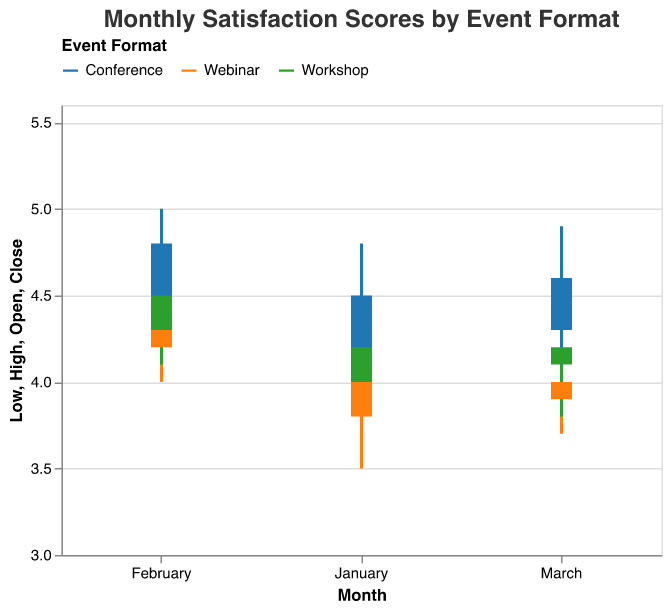What is the title of the plot? The title is usually placed at the top of the figure and is meant to inform the viewer about the overall topic of the plot. In this case, the title is "Monthly Satisfaction Scores by Event Format".
Answer: Monthly Satisfaction Scores by Event Format How many different event formats are being compared in the plot? Event formats are color-coded and represented in the legend. The three distinct colors indicate three event formats: Webinar, Workshop, and Conference.
Answer: Three For which event format was the highest satisfaction score recorded, and in which month did it occur? The highest satisfaction score is determined by identifying the peak value among the candlestick High values. Conferences in February had the highest score of 5.0.
Answer: Conference, February What is the lowest satisfaction score for workshops in any month? To find the lowest value, we need to look at the Low values of the candlesticks representing workshops. The lowest value for workshops is 3.8 in March.
Answer: 3.8 Did the satisfaction score for webinars improve, decline, or remain stable from January to March? To determine the trend for webinars, we need to look at the Open values for January, February, and March and compare them with the Close values for the same months. From January to February, the score increased (4.1 to 4.6), and it decreased from February to March (4.6 to 4.0).
Answer: Decline Which event format had the smallest range (High-Low) in March? The range is calculated as the difference between High and Low values for each format in March. For webinars, the range is 4.4 - 3.7 = 0.7; for workshops, it's 4.6 - 3.8 = 0.8; for conferences, it's 4.9 - 4.1 = 0.8. Therefore, webinars have the smallest range.
Answer: Webinar What was the median Close value for conferences across the three months? To find the median, we need the three Close values for conferences: January (4.5), February (4.8), and March (4.6). Sorting these values gives 4.5, 4.6, and 4.8. The median (middle value) is 4.6.
Answer: 4.6 Compare the overall satisfaction stability of workshops and webinars. Which format had more stable satisfaction scores? Stability refers to smaller fluctuations in values. By examining the differences between Open and Close for each month: Workshops: (4.3-4.0, 4.7-4.3, 4.2-4.1) = (0.3, 0.4, 0.1); Webinars: (4.1-3.8, 4.6-4.2, 4.0-3.9) = (0.3, 0.4, 0.1). Both have small and similar differences, indicating similar stability.
Answer: Both equally stable 